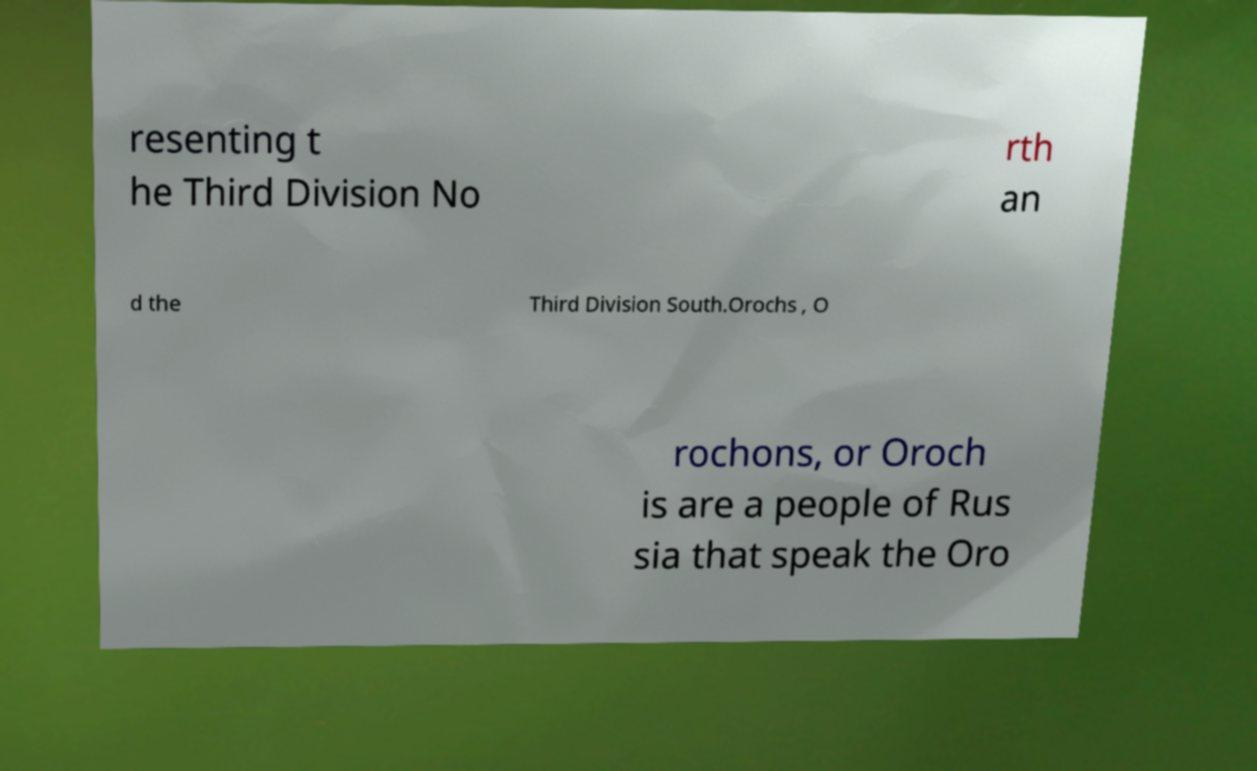Could you assist in decoding the text presented in this image and type it out clearly? resenting t he Third Division No rth an d the Third Division South.Orochs , O rochons, or Oroch is are a people of Rus sia that speak the Oro 